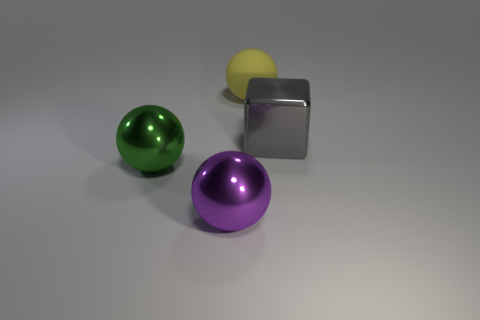Add 1 red cubes. How many objects exist? 5 Subtract all balls. How many objects are left? 1 Subtract all blue rubber cylinders. Subtract all large green objects. How many objects are left? 3 Add 3 big green things. How many big green things are left? 4 Add 1 large shiny blocks. How many large shiny blocks exist? 2 Subtract 0 gray balls. How many objects are left? 4 